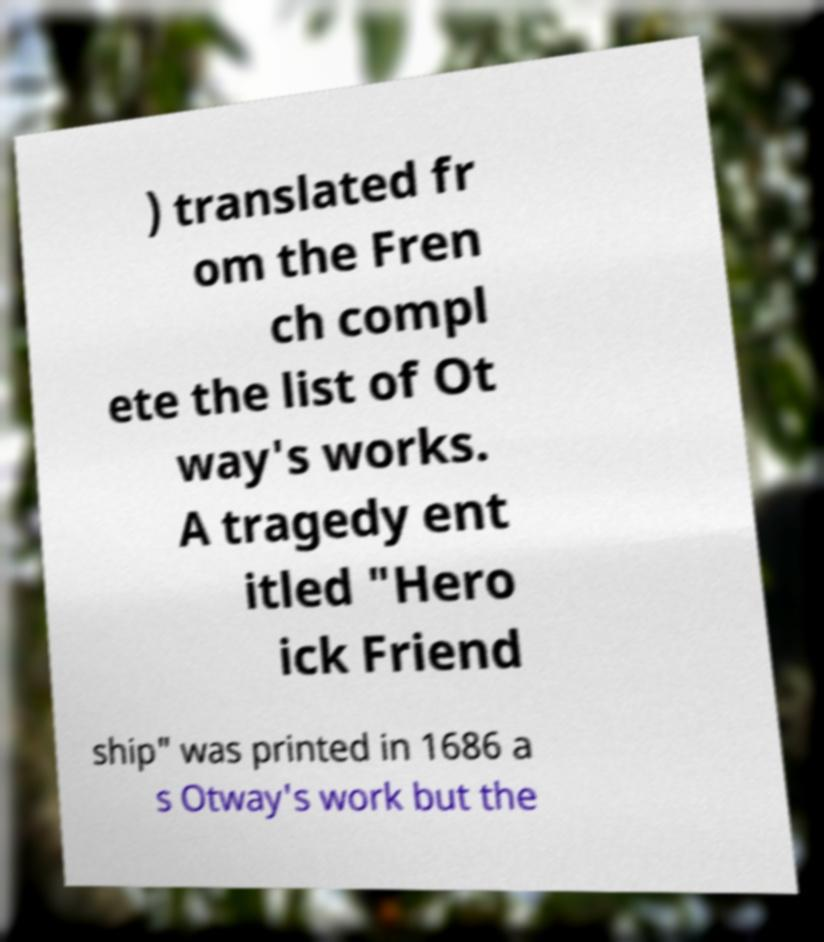What messages or text are displayed in this image? I need them in a readable, typed format. ) translated fr om the Fren ch compl ete the list of Ot way's works. A tragedy ent itled "Hero ick Friend ship" was printed in 1686 a s Otway's work but the 